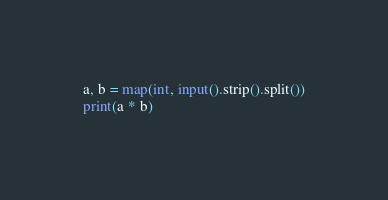<code> <loc_0><loc_0><loc_500><loc_500><_Python_>a, b = map(int, input().strip().split())
print(a * b)</code> 